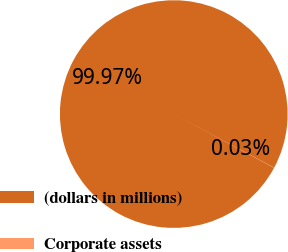<chart> <loc_0><loc_0><loc_500><loc_500><pie_chart><fcel>(dollars in millions)<fcel>Corporate assets<nl><fcel>99.97%<fcel>0.03%<nl></chart> 